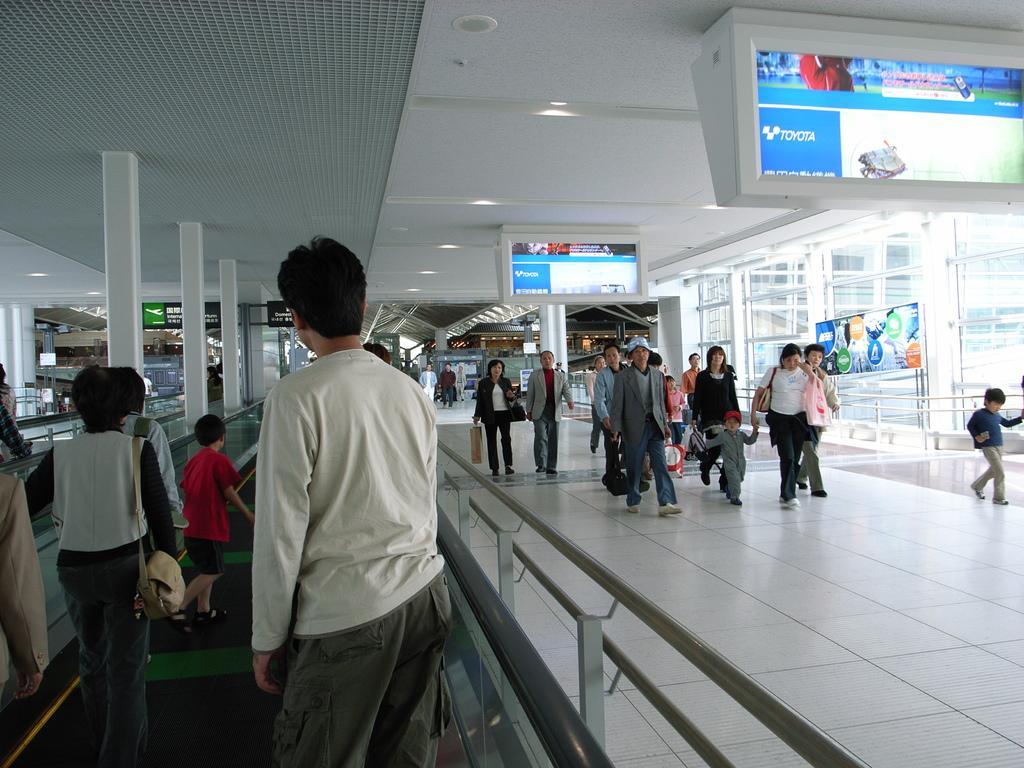In one or two sentences, can you explain what this image depicts? This picture is an inside view of a building. In this picture we can see the stores, boards, some persons, wall, glass, pillars. On the left side of the image we can see an escalator, some persons. At the top of the image we can see the roof and lights. At the bottom of the image we can see the floor. 